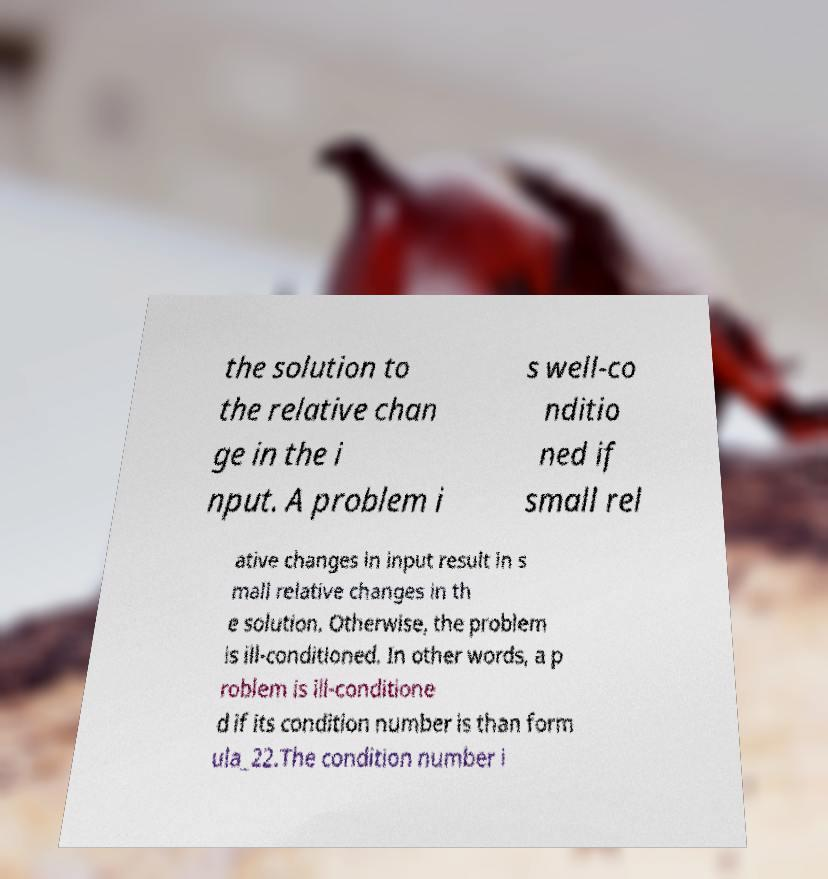Please read and relay the text visible in this image. What does it say? the solution to the relative chan ge in the i nput. A problem i s well-co nditio ned if small rel ative changes in input result in s mall relative changes in th e solution. Otherwise, the problem is ill-conditioned. In other words, a p roblem is ill-conditione d if its condition number is than form ula_22.The condition number i 